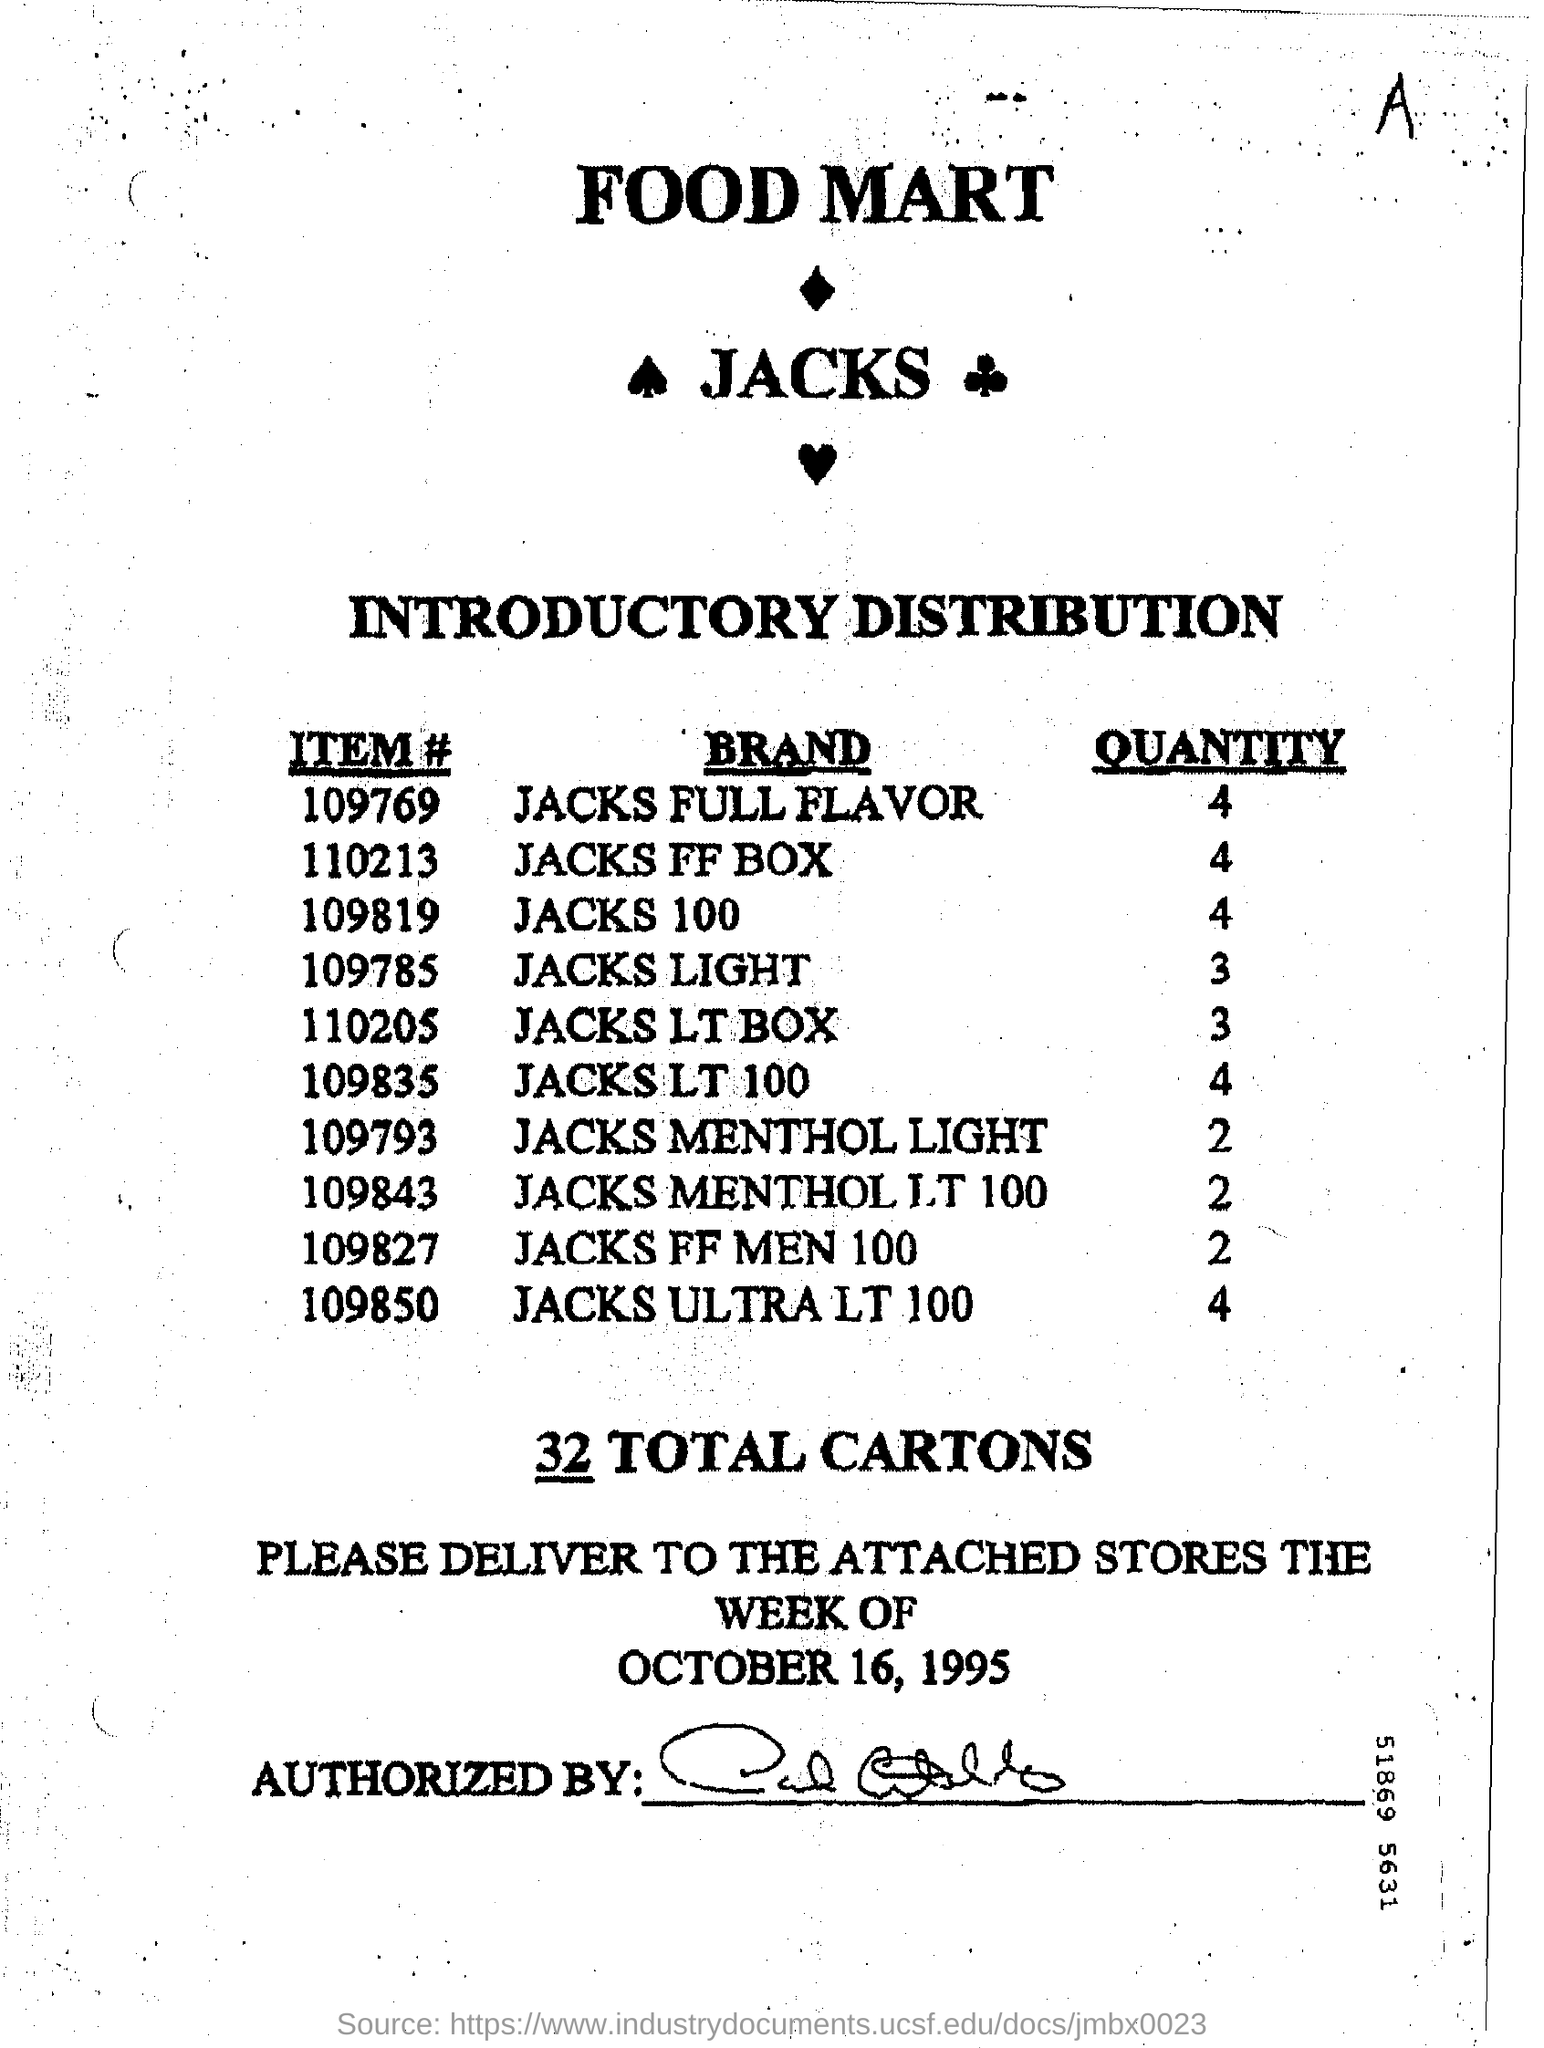What is the Item # for Jacks Full Flavor?
Your response must be concise. 109769. What is the Item # for Jacks FF Box?
Provide a short and direct response. 110213. What is the Item # for Jacks Light?
Provide a short and direct response. 109785. What is the Item # for Jacks LT 100?
Your answer should be very brief. 109835. What is the Item # for Jacks 100?
Offer a very short reply. 109819. What is the Quantity for Jacks Full Flavor?
Your answer should be very brief. 4. What is the Quantity for Jacks 100?
Your answer should be compact. 4. What is the Quantity for Jacks Light?
Offer a terse response. 3. What is the Quantity for Jacks LT 100?
Provide a short and direct response. 4. How many Total Cartons?
Your answer should be very brief. 32. 